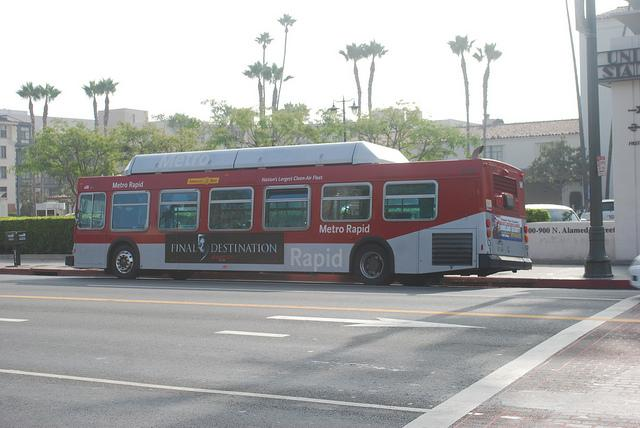What type of vehicle is this?

Choices:
A) watercraft
B) cargo
C) construction
D) passenger passenger 